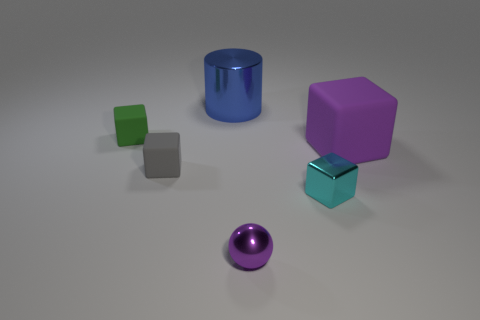Subtract all blue blocks. Subtract all purple cylinders. How many blocks are left? 4 Add 3 purple matte blocks. How many objects exist? 9 Subtract all balls. How many objects are left? 5 Add 3 big brown shiny blocks. How many big brown shiny blocks exist? 3 Subtract 1 purple cubes. How many objects are left? 5 Subtract all tiny metallic blocks. Subtract all blue metallic objects. How many objects are left? 4 Add 2 tiny purple things. How many tiny purple things are left? 3 